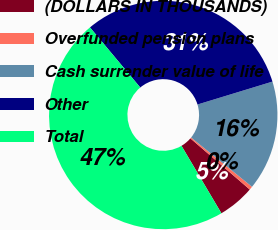Convert chart to OTSL. <chart><loc_0><loc_0><loc_500><loc_500><pie_chart><fcel>(DOLLARS IN THOUSANDS)<fcel>Overfunded pension plans<fcel>Cash surrender value of life<fcel>Other<fcel>Total<nl><fcel>5.18%<fcel>0.49%<fcel>15.55%<fcel>31.37%<fcel>47.41%<nl></chart> 